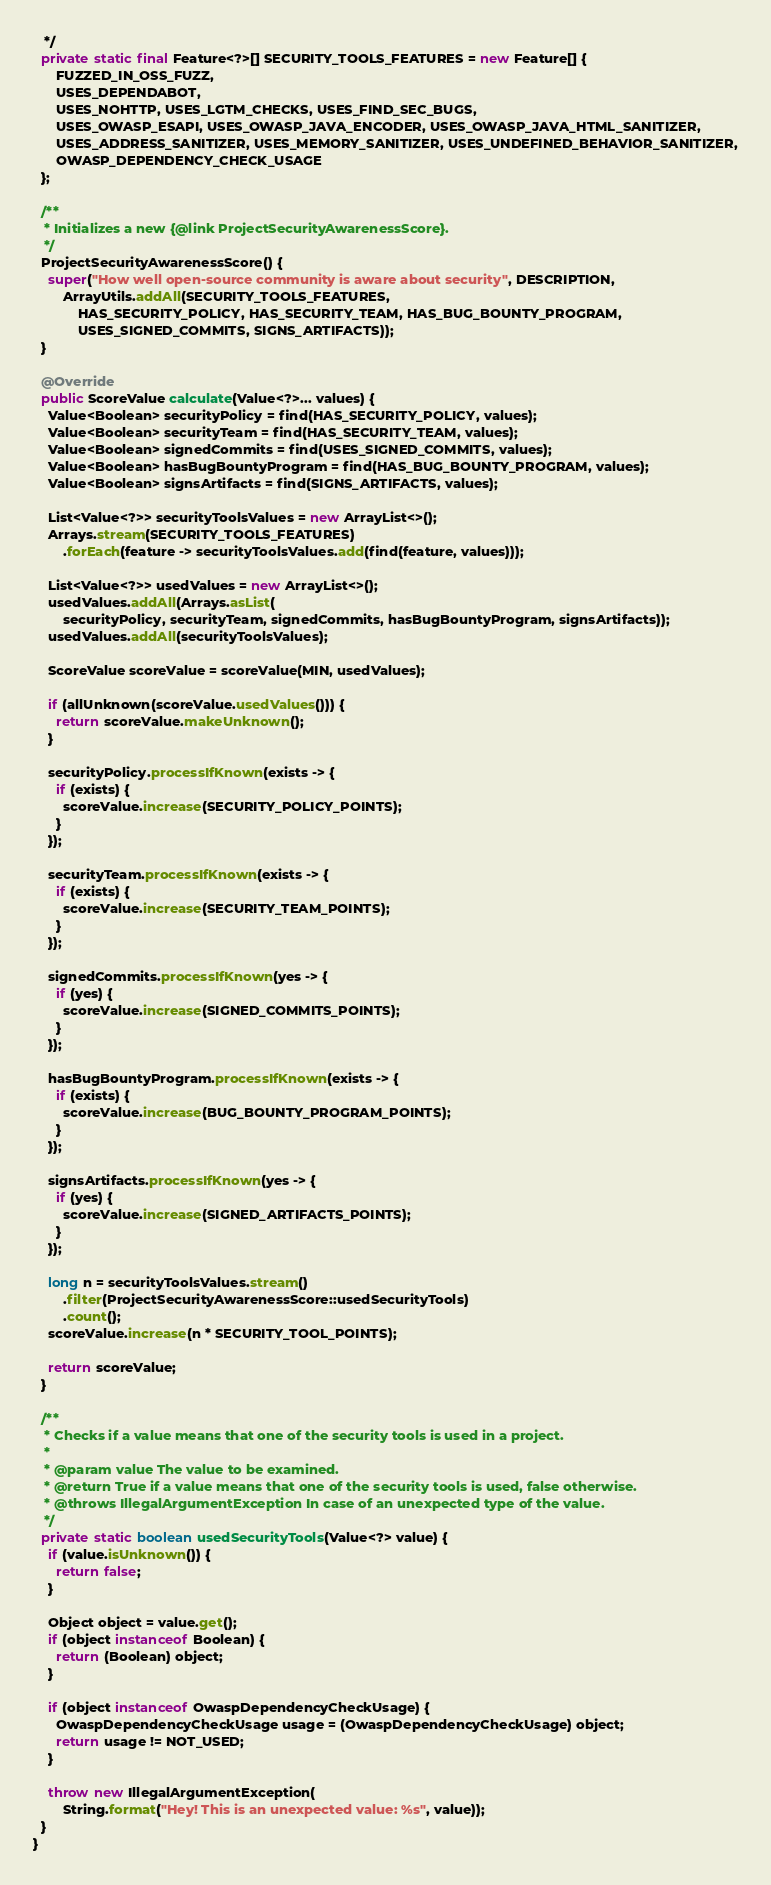<code> <loc_0><loc_0><loc_500><loc_500><_Java_>   */
  private static final Feature<?>[] SECURITY_TOOLS_FEATURES = new Feature[] {
      FUZZED_IN_OSS_FUZZ,
      USES_DEPENDABOT,
      USES_NOHTTP, USES_LGTM_CHECKS, USES_FIND_SEC_BUGS,
      USES_OWASP_ESAPI, USES_OWASP_JAVA_ENCODER, USES_OWASP_JAVA_HTML_SANITIZER,
      USES_ADDRESS_SANITIZER, USES_MEMORY_SANITIZER, USES_UNDEFINED_BEHAVIOR_SANITIZER,
      OWASP_DEPENDENCY_CHECK_USAGE
  };

  /**
   * Initializes a new {@link ProjectSecurityAwarenessScore}.
   */
  ProjectSecurityAwarenessScore() {
    super("How well open-source community is aware about security", DESCRIPTION,
        ArrayUtils.addAll(SECURITY_TOOLS_FEATURES,
            HAS_SECURITY_POLICY, HAS_SECURITY_TEAM, HAS_BUG_BOUNTY_PROGRAM,
            USES_SIGNED_COMMITS, SIGNS_ARTIFACTS));
  }

  @Override
  public ScoreValue calculate(Value<?>... values) {
    Value<Boolean> securityPolicy = find(HAS_SECURITY_POLICY, values);
    Value<Boolean> securityTeam = find(HAS_SECURITY_TEAM, values);
    Value<Boolean> signedCommits = find(USES_SIGNED_COMMITS, values);
    Value<Boolean> hasBugBountyProgram = find(HAS_BUG_BOUNTY_PROGRAM, values);
    Value<Boolean> signsArtifacts = find(SIGNS_ARTIFACTS, values);

    List<Value<?>> securityToolsValues = new ArrayList<>();
    Arrays.stream(SECURITY_TOOLS_FEATURES)
        .forEach(feature -> securityToolsValues.add(find(feature, values)));

    List<Value<?>> usedValues = new ArrayList<>();
    usedValues.addAll(Arrays.asList(
        securityPolicy, securityTeam, signedCommits, hasBugBountyProgram, signsArtifacts));
    usedValues.addAll(securityToolsValues);

    ScoreValue scoreValue = scoreValue(MIN, usedValues);

    if (allUnknown(scoreValue.usedValues())) {
      return scoreValue.makeUnknown();
    }

    securityPolicy.processIfKnown(exists -> {
      if (exists) {
        scoreValue.increase(SECURITY_POLICY_POINTS);
      }
    });

    securityTeam.processIfKnown(exists -> {
      if (exists) {
        scoreValue.increase(SECURITY_TEAM_POINTS);
      }
    });

    signedCommits.processIfKnown(yes -> {
      if (yes) {
        scoreValue.increase(SIGNED_COMMITS_POINTS);
      }
    });

    hasBugBountyProgram.processIfKnown(exists -> {
      if (exists) {
        scoreValue.increase(BUG_BOUNTY_PROGRAM_POINTS);
      }
    });

    signsArtifacts.processIfKnown(yes -> {
      if (yes) {
        scoreValue.increase(SIGNED_ARTIFACTS_POINTS);
      }
    });

    long n = securityToolsValues.stream()
        .filter(ProjectSecurityAwarenessScore::usedSecurityTools)
        .count();
    scoreValue.increase(n * SECURITY_TOOL_POINTS);

    return scoreValue;
  }

  /**
   * Checks if a value means that one of the security tools is used in a project.
   *
   * @param value The value to be examined.
   * @return True if a value means that one of the security tools is used, false otherwise.
   * @throws IllegalArgumentException In case of an unexpected type of the value.
   */
  private static boolean usedSecurityTools(Value<?> value) {
    if (value.isUnknown()) {
      return false;
    }

    Object object = value.get();
    if (object instanceof Boolean) {
      return (Boolean) object;
    }

    if (object instanceof OwaspDependencyCheckUsage) {
      OwaspDependencyCheckUsage usage = (OwaspDependencyCheckUsage) object;
      return usage != NOT_USED;
    }

    throw new IllegalArgumentException(
        String.format("Hey! This is an unexpected value: %s", value));
  }
}
</code> 